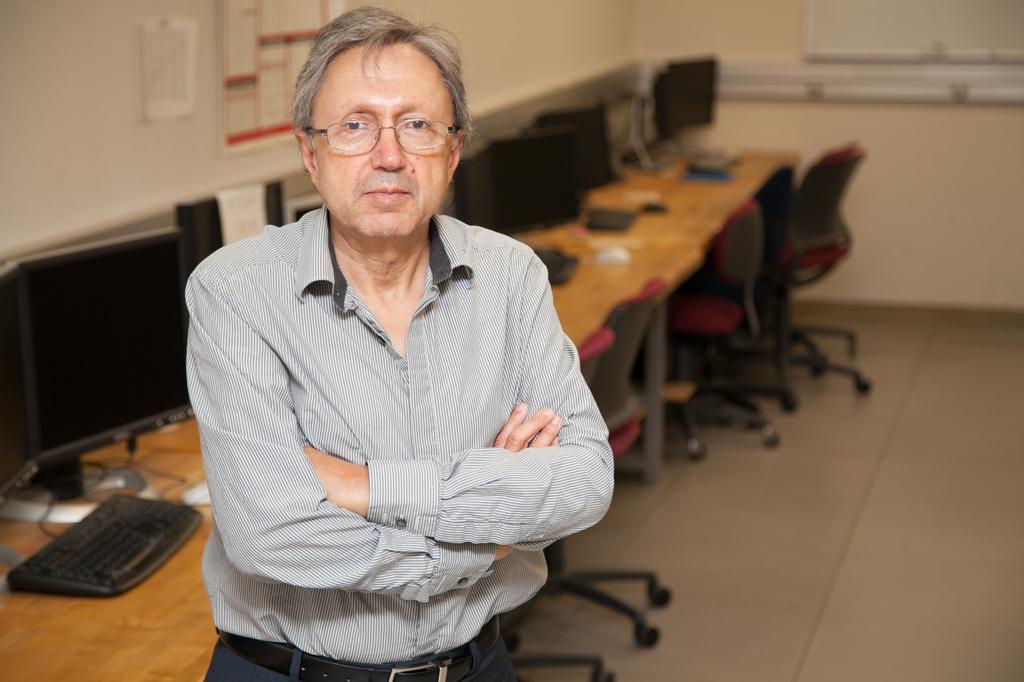Describe this image in one or two sentences. In picture there is a room in which a person is standing there are many chairs in front of a table on the table there are many systems with the keyboard and mouse on the wall there are some stickers. 